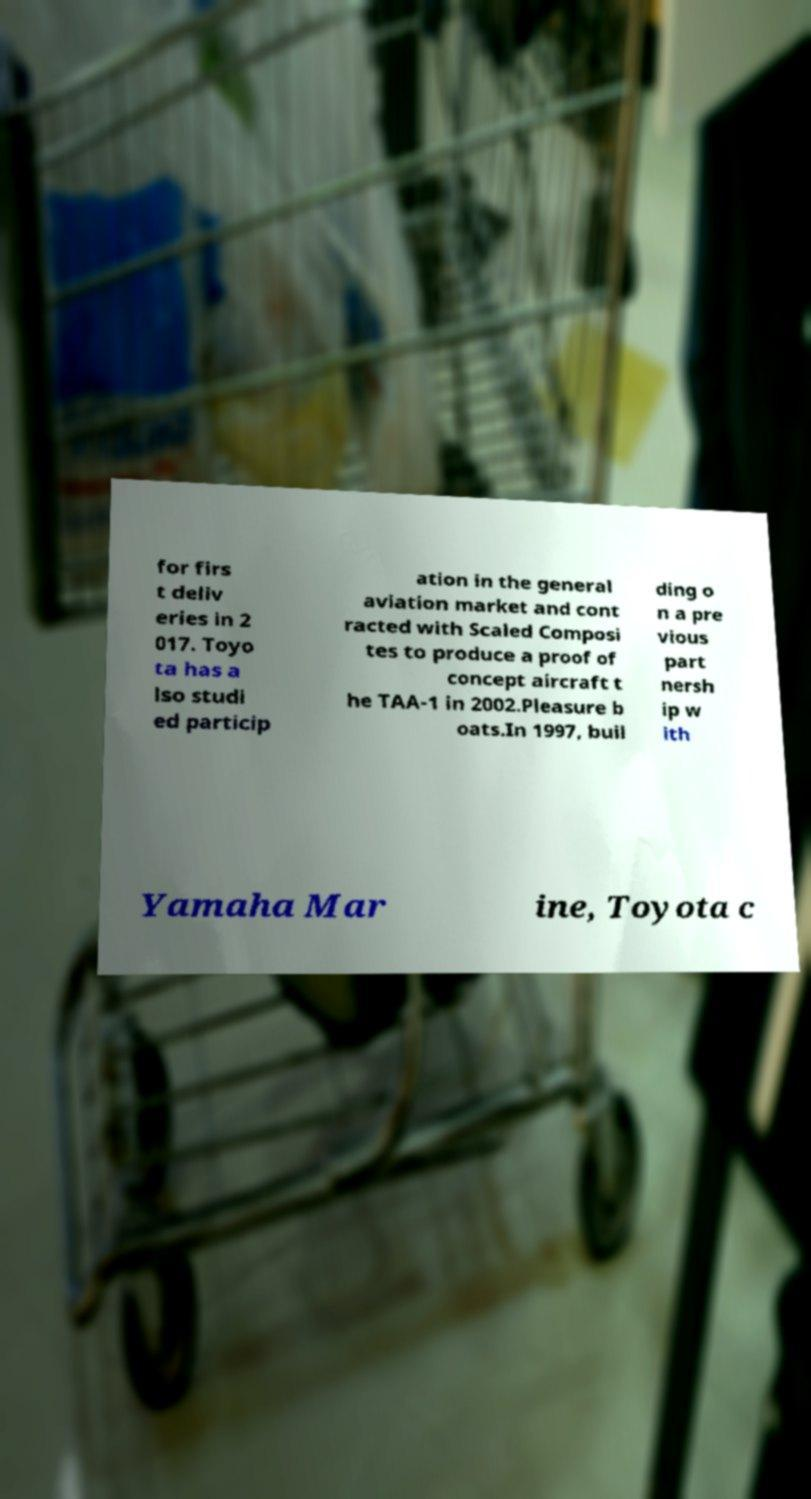For documentation purposes, I need the text within this image transcribed. Could you provide that? for firs t deliv eries in 2 017. Toyo ta has a lso studi ed particip ation in the general aviation market and cont racted with Scaled Composi tes to produce a proof of concept aircraft t he TAA-1 in 2002.Pleasure b oats.In 1997, buil ding o n a pre vious part nersh ip w ith Yamaha Mar ine, Toyota c 